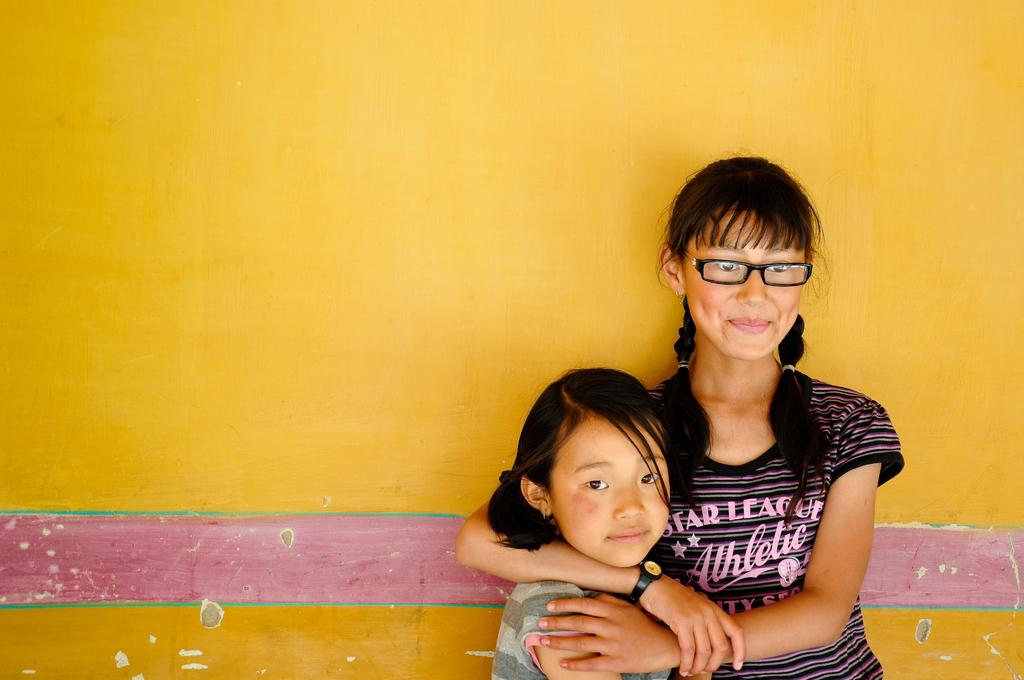What can be seen in the image? There are children standing in the image. What is visible in the background of the image? There is a wall in the background of the image. What type of waves can be seen in the image? There are no waves present in the image; it features children standing in front of a wall. 